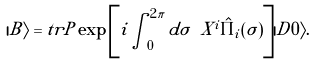<formula> <loc_0><loc_0><loc_500><loc_500>| B \rangle = t r P \exp \left [ i \int _ { 0 } ^ { 2 \pi } d \sigma \ X ^ { i } \hat { \Pi } _ { i } ( \sigma ) \right ] | D 0 \rangle .</formula> 